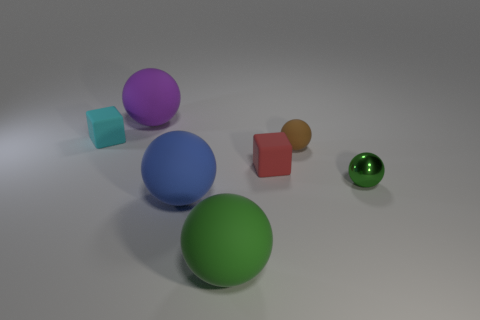There is a small ball that is behind the green ball right of the red object; are there any purple rubber balls that are behind it?
Offer a very short reply. Yes. Is the tiny thing that is in front of the tiny red block made of the same material as the purple ball?
Offer a very short reply. No. What color is the other small thing that is the same shape as the small red matte thing?
Keep it short and to the point. Cyan. Are there an equal number of brown rubber spheres that are to the left of the blue matte thing and green metal balls?
Offer a terse response. No. Are there any rubber things in front of the small green sphere?
Give a very brief answer. Yes. How big is the rubber block in front of the matte cube to the left of the green sphere that is left of the small green shiny thing?
Your answer should be compact. Small. Do the green object left of the small brown matte ball and the small matte object that is to the left of the blue object have the same shape?
Your answer should be very brief. No. What size is the green matte thing that is the same shape as the shiny object?
Provide a succinct answer. Large. How many big brown cubes are the same material as the small brown thing?
Provide a succinct answer. 0. What material is the cyan thing?
Provide a succinct answer. Rubber. 